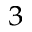<formula> <loc_0><loc_0><loc_500><loc_500>^ { 3 }</formula> 